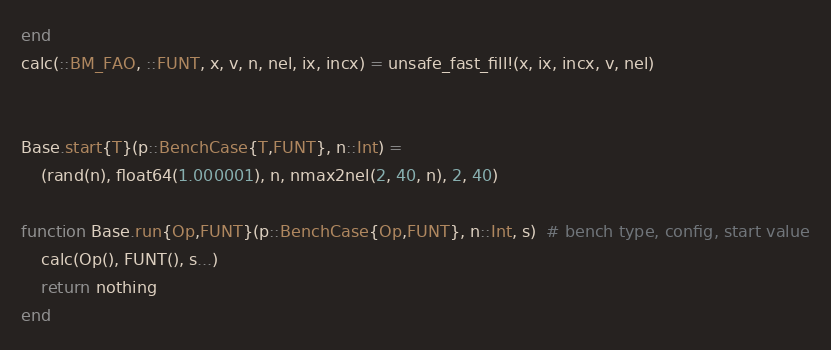Convert code to text. <code><loc_0><loc_0><loc_500><loc_500><_Julia_>end
calc(::BM_FAO, ::FUNT, x, v, n, nel, ix, incx) = unsafe_fast_fill!(x, ix, incx, v, nel)


Base.start{T}(p::BenchCase{T,FUNT}, n::Int) = 
    (rand(n), float64(1.000001), n, nmax2nel(2, 40, n), 2, 40)

function Base.run{Op,FUNT}(p::BenchCase{Op,FUNT}, n::Int, s)  # bench type, config, start value
    calc(Op(), FUNT(), s...)
    return nothing
end

</code> 